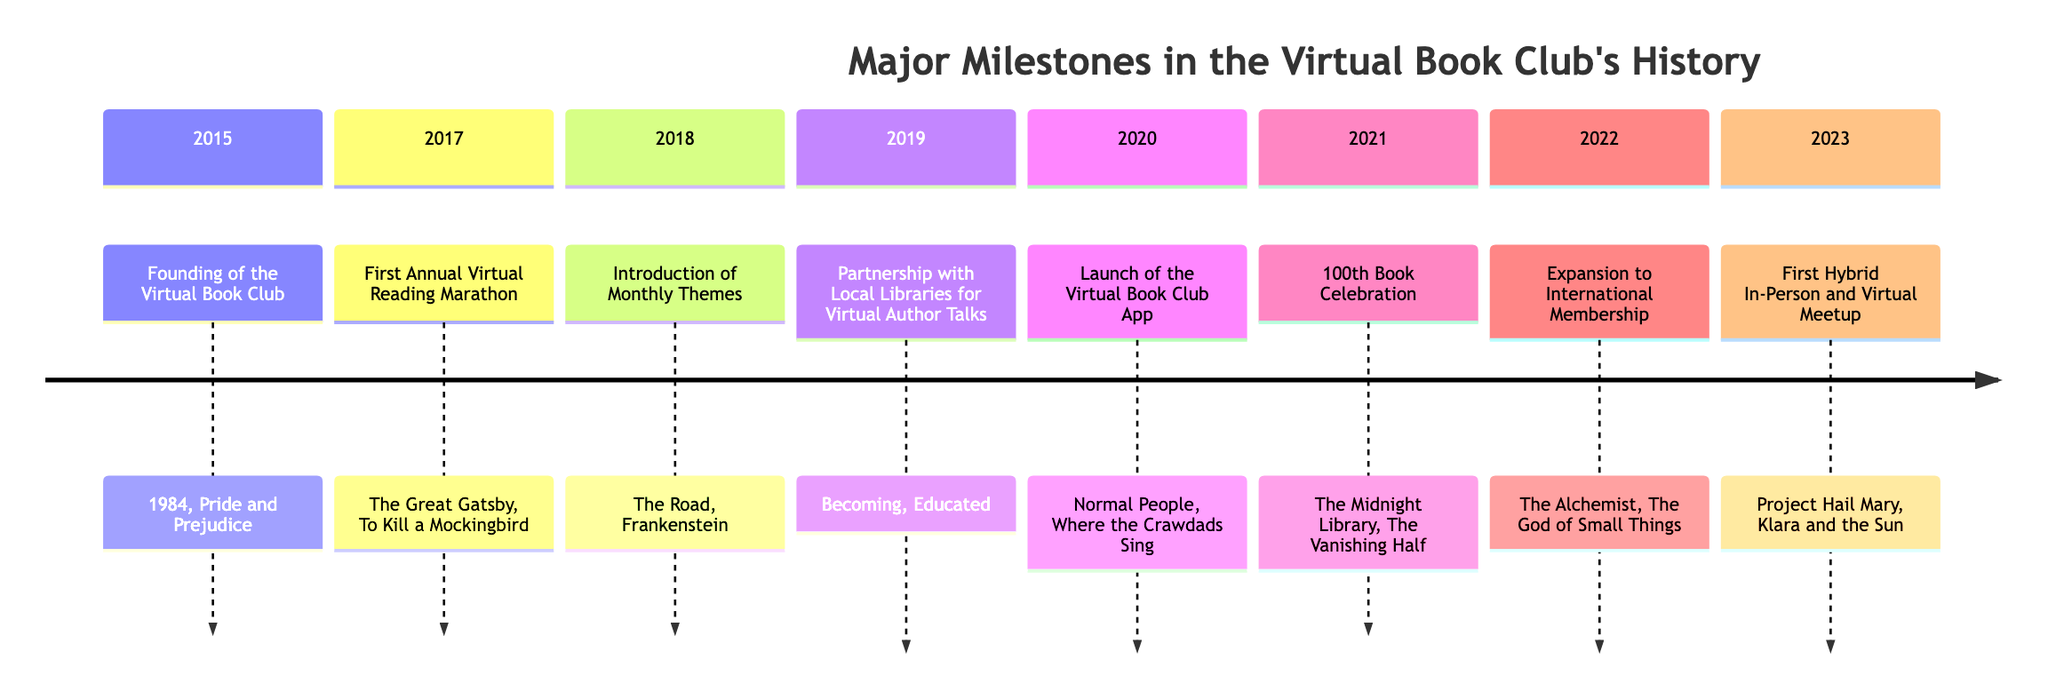What year was the Virtual Book Club founded? The timeline indicates that the founding event is listed under the year 2015. Thus, the answer to the question is directly tied to that specific year.
Answer: 2015 What event occurred in 2018? By looking at the timeline, the event listed for the year 2018 is the "Introduction of Monthly Themes." The answer comes from directly referencing the specific section of the timeline.
Answer: Introduction of Monthly Themes Which book was key in 2021? For the year 2021, the timeline shows "The Midnight Library" as one of the key readings. This is a direct reference from the section indicating that particular year.
Answer: The Midnight Library How many events occurred before 2022? There are events listed for the years 2015, 2017, 2018, 2019, 2020, and 2021. Counting these events yields a total of six events before 2022.
Answer: 6 What were the key readings in the year 2019? The timeline shows that in 2019, the key readings are "Becoming" by Michelle Obama and "Educated" by Tara Westover. The answer is based on extracting the specific information for that year from the timeline.
Answer: Becoming, Educated Which year's event relates to local libraries? From the timeline, the year 2019 is specified for the event "Partnership with Local Libraries for Virtual Author Talks." Thus, by identifying the context of local libraries in the events, the answer is drawn directly from the timeline.
Answer: 2019 What year did the Virtual Book Club App launch? The timeline indicates that the launch of the Virtual Book Club App occurred in 2020. The answer is found by locating the specific event under that year in the diagram.
Answer: 2020 Which two books were featured in the first annual Virtual Reading Marathon? The timeline section for 2017 lists "The Great Gatsby" and "To Kill a Mockingbird" as the key readings for that event. The answer is extracted from specifically denoting those titles in the timeline for 2017.
Answer: The Great Gatsby, To Kill a Mockingbird What milestone was celebrated in 2021? The timeline specifies the "100th Book Celebration" for the year 2021. This is a direct identification of the event listed in that year of the timeline.
Answer: 100th Book Celebration 